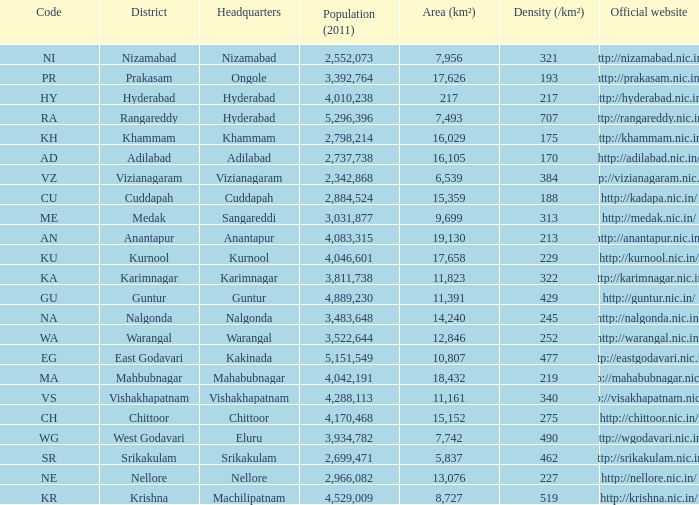What is the sum of the area values for districts having density over 462 and websites of http://krishna.nic.in/? 8727.0. 